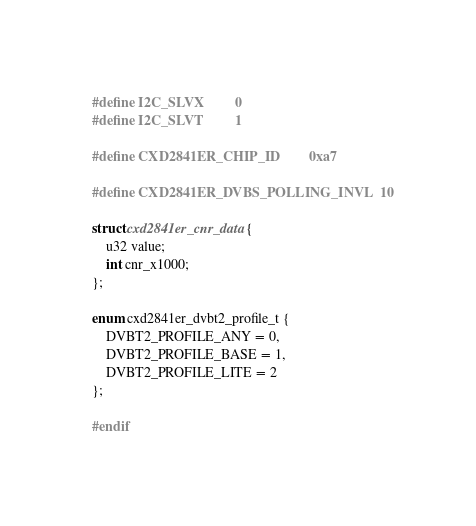Convert code to text. <code><loc_0><loc_0><loc_500><loc_500><_C_>#define I2C_SLVX			0
#define I2C_SLVT			1

#define CXD2841ER_CHIP_ID		0xa7

#define CXD2841ER_DVBS_POLLING_INVL	10

struct cxd2841er_cnr_data {
	u32 value;
	int cnr_x1000;
};

enum cxd2841er_dvbt2_profile_t {
	DVBT2_PROFILE_ANY = 0,
	DVBT2_PROFILE_BASE = 1,
	DVBT2_PROFILE_LITE = 2
};

#endif
</code> 